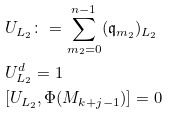<formula> <loc_0><loc_0><loc_500><loc_500>& U _ { L _ { 2 } } \colon = \sum _ { m _ { 2 } = 0 } ^ { n - 1 } ( { \mathfrak q } _ { m _ { 2 } } ) _ { L _ { 2 } } \\ & U _ { L _ { 2 } } ^ { d } = { 1 } \\ & [ U _ { L _ { 2 } } , \Phi ( M _ { k + j - 1 } ) ] = 0</formula> 